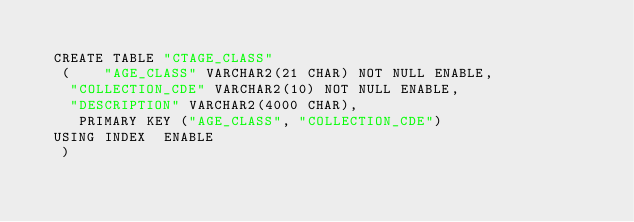Convert code to text. <code><loc_0><loc_0><loc_500><loc_500><_SQL_>
  CREATE TABLE "CTAGE_CLASS" 
   (	"AGE_CLASS" VARCHAR2(21 CHAR) NOT NULL ENABLE, 
	"COLLECTION_CDE" VARCHAR2(10) NOT NULL ENABLE, 
	"DESCRIPTION" VARCHAR2(4000 CHAR), 
	 PRIMARY KEY ("AGE_CLASS", "COLLECTION_CDE")
  USING INDEX  ENABLE
   ) </code> 